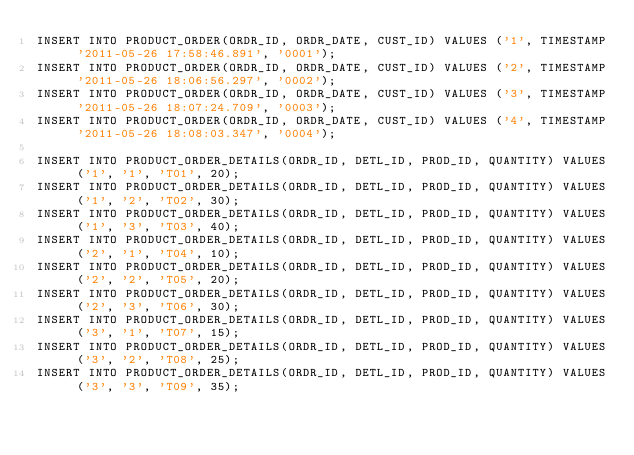Convert code to text. <code><loc_0><loc_0><loc_500><loc_500><_SQL_>INSERT INTO PRODUCT_ORDER(ORDR_ID, ORDR_DATE, CUST_ID) VALUES ('1', TIMESTAMP '2011-05-26 17:58:46.891', '0001');
INSERT INTO PRODUCT_ORDER(ORDR_ID, ORDR_DATE, CUST_ID) VALUES ('2', TIMESTAMP '2011-05-26 18:06:56.297', '0002');
INSERT INTO PRODUCT_ORDER(ORDR_ID, ORDR_DATE, CUST_ID) VALUES ('3', TIMESTAMP '2011-05-26 18:07:24.709', '0003');
INSERT INTO PRODUCT_ORDER(ORDR_ID, ORDR_DATE, CUST_ID) VALUES ('4', TIMESTAMP '2011-05-26 18:08:03.347', '0004');

INSERT INTO PRODUCT_ORDER_DETAILS(ORDR_ID, DETL_ID, PROD_ID, QUANTITY) VALUES ('1', '1', 'T01', 20);
INSERT INTO PRODUCT_ORDER_DETAILS(ORDR_ID, DETL_ID, PROD_ID, QUANTITY) VALUES ('1', '2', 'T02', 30);
INSERT INTO PRODUCT_ORDER_DETAILS(ORDR_ID, DETL_ID, PROD_ID, QUANTITY) VALUES ('1', '3', 'T03', 40);
INSERT INTO PRODUCT_ORDER_DETAILS(ORDR_ID, DETL_ID, PROD_ID, QUANTITY) VALUES ('2', '1', 'T04', 10);
INSERT INTO PRODUCT_ORDER_DETAILS(ORDR_ID, DETL_ID, PROD_ID, QUANTITY) VALUES ('2', '2', 'T05', 20);
INSERT INTO PRODUCT_ORDER_DETAILS(ORDR_ID, DETL_ID, PROD_ID, QUANTITY) VALUES ('2', '3', 'T06', 30);
INSERT INTO PRODUCT_ORDER_DETAILS(ORDR_ID, DETL_ID, PROD_ID, QUANTITY) VALUES ('3', '1', 'T07', 15);
INSERT INTO PRODUCT_ORDER_DETAILS(ORDR_ID, DETL_ID, PROD_ID, QUANTITY) VALUES ('3', '2', 'T08', 25);
INSERT INTO PRODUCT_ORDER_DETAILS(ORDR_ID, DETL_ID, PROD_ID, QUANTITY) VALUES ('3', '3', 'T09', 35);</code> 